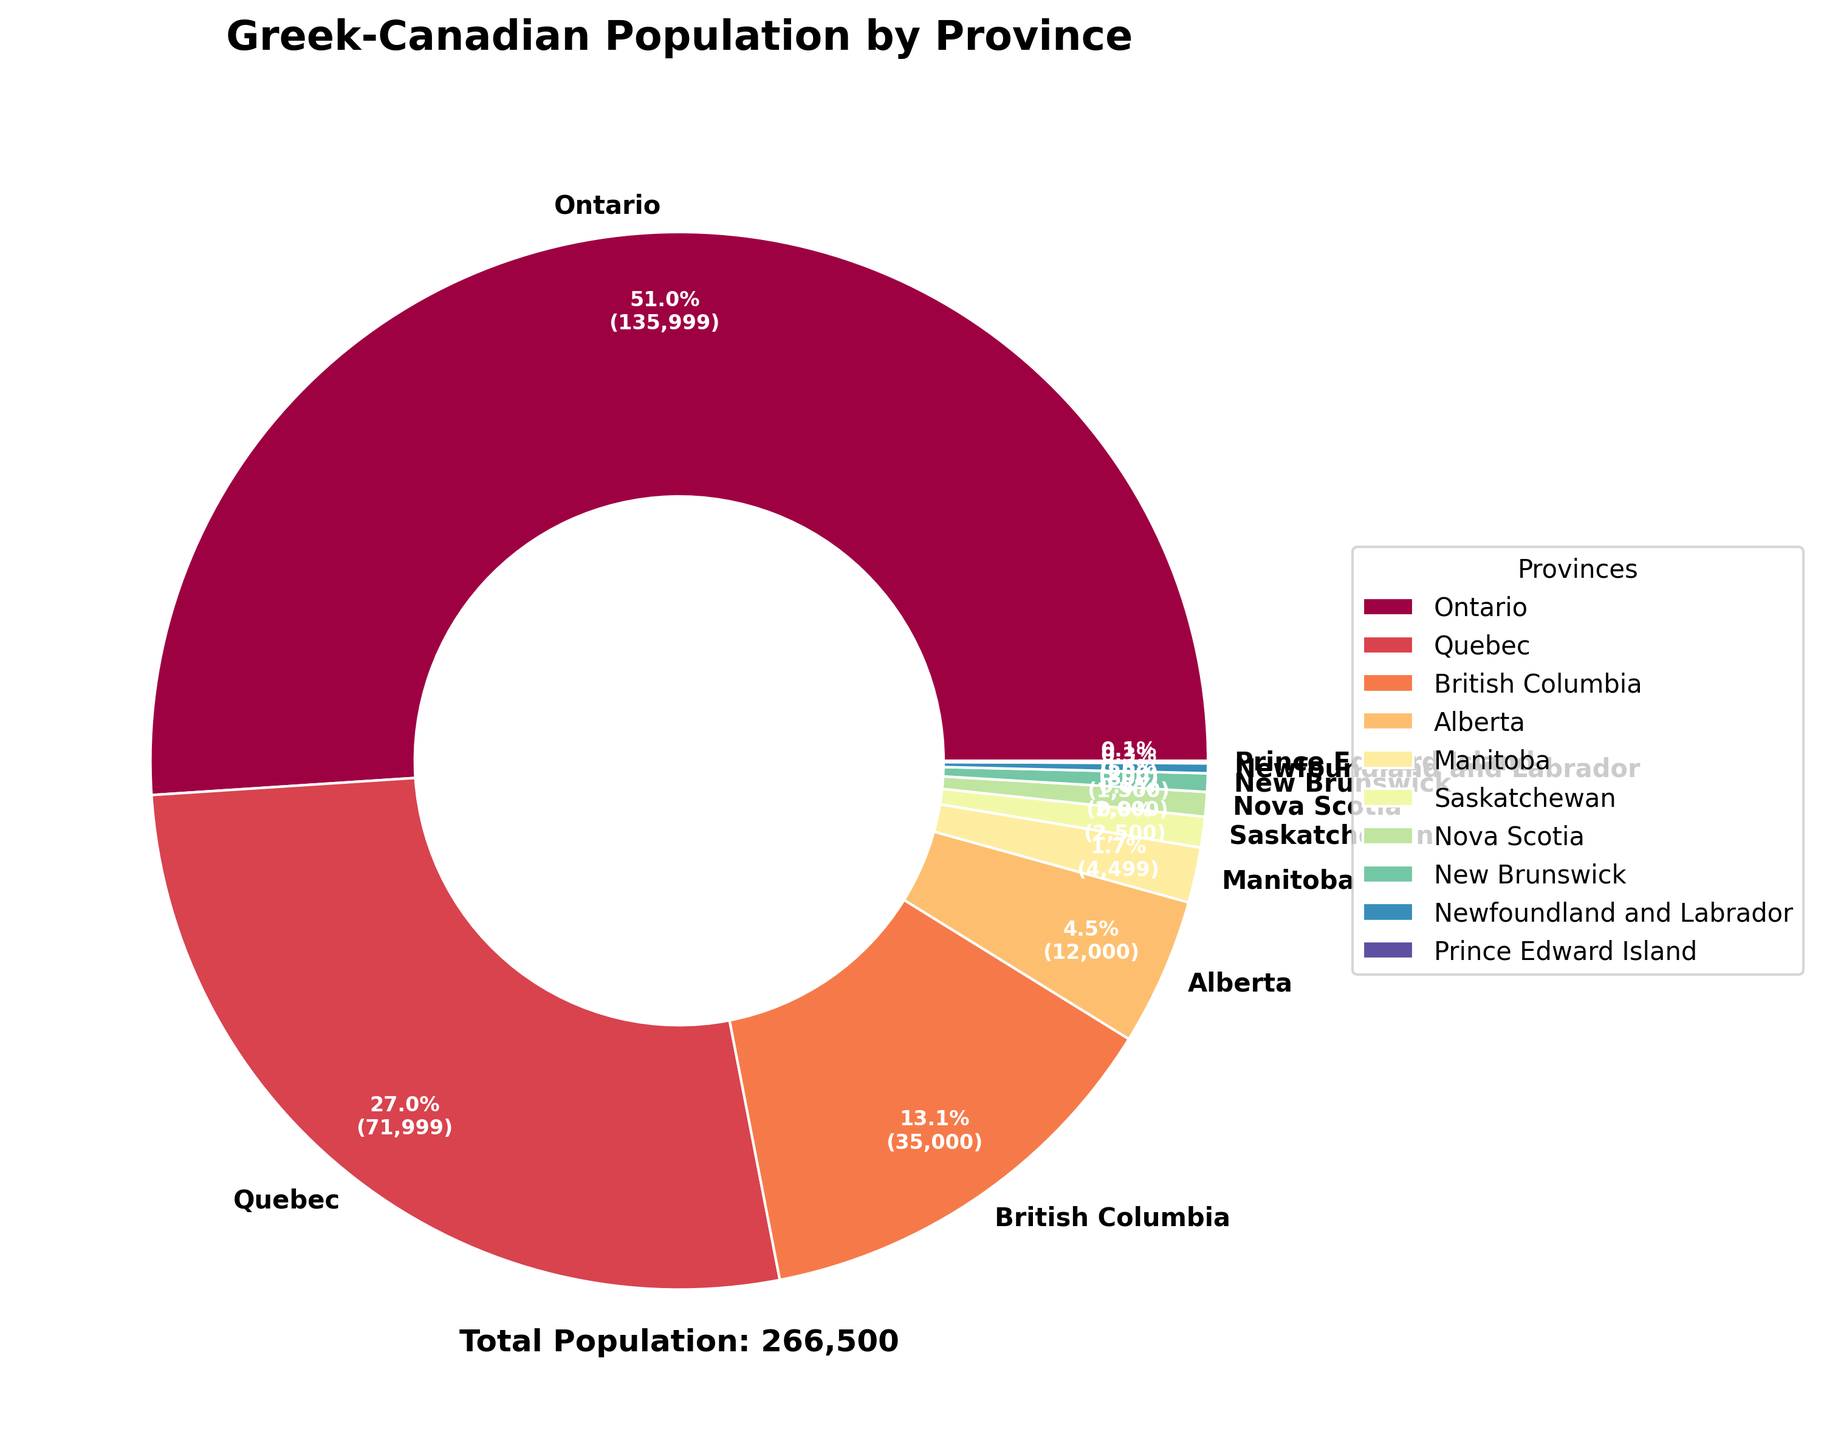What province has the highest population of Greek-Canadians? Look at the pie chart and see which province has the largest section. The label and percentage on the largest section indicate the province.
Answer: Ontario Which provinces have a lower Greek-Canadian population than Manitoba? Compare the population values of Manitoba with other provinces. Manitoba has 4,500 people. Looking at the sections smaller than this, we find Saskatchewan, Nova Scotia, New Brunswick, Newfoundland and Labrador, and Prince Edward Island.
Answer: Saskatchewan, Nova Scotia, New Brunswick, Newfoundland and Labrador, Prince Edward Island What is the total Greek-Canadian population in Alberta and British Columbia combined? Alberta has 12,000 and British Columbia has 35,000. Adding these two populations together gives us 12,000 + 35,000 = 47,000.
Answer: 47,000 Which province has a larger Greek-Canadian population: Quebec or British Columbia? Compare the sections for Quebec and British Columbia. Quebec has 72,000 Greek-Canadians, while British Columbia has 35,000. Quebec has a larger population.
Answer: Quebec What is the percentage of the Greek-Canadian population in Nova Scotia compared to the total? Nova Scotia has 2,000 Greek-Canadians. The total population is 265,500. Calculate the percentage as (2,000 / 265,500) * 100.
Answer: 0.8% Which provinces together make up more than 50% of the Greek-Canadian population? Summing the population percentages from the pie chart sections, Ontario (51.2%) and Quebec (27.1%) together exceed 50%.
Answer: Ontario and Quebec What is the difference in Greek-Canadian population between Ontario and Alberta? Ontario has 136,000 and Alberta has 12,000. Subtracting Alberta's population from Ontario's gives us 136,000 - 12,000 = 124,000.
Answer: 124,000 Which provinces make up the smallest combined Greek-Canadian population? The smallest populations, visually, are in Newfoundland and Labrador (800) and Prince Edward Island (200). Adding these gives 800 + 200 = 1,000.
Answer: Newfoundland and Labrador, Prince Edward Island What percentage of the Greek-Canadian population does Ontario have? Ontario has 136,000 Greek-Canadians out of a total of 265,500. The percentage is (136,000 / 265,500) * 100.
Answer: 51.2% How many more Greek-Canadians are there in Quebec than in Manitoba? Quebec has 72,000 Greek-Canadians and Manitoba has 4,500. Subtracting the population of Manitoba from Quebec gives us 72,000 - 4,500 = 67,500.
Answer: 67,500 